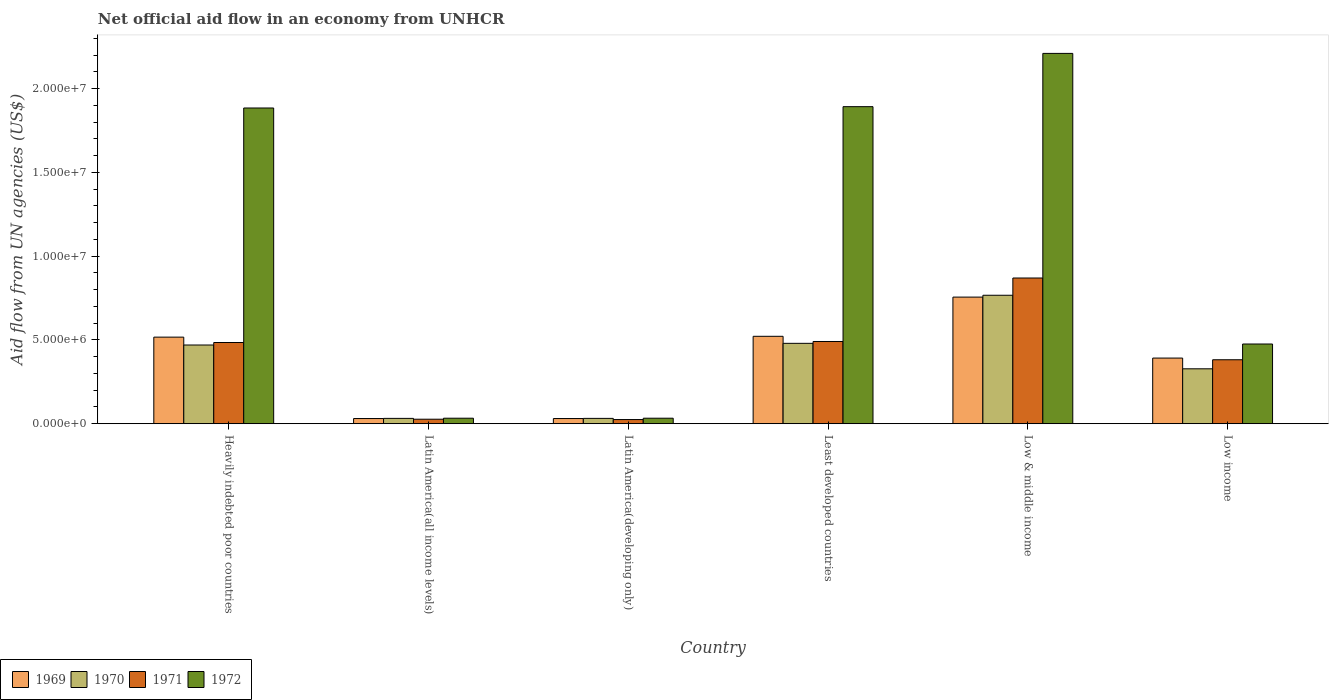How many groups of bars are there?
Offer a terse response. 6. Are the number of bars per tick equal to the number of legend labels?
Keep it short and to the point. Yes. How many bars are there on the 2nd tick from the left?
Your response must be concise. 4. What is the label of the 5th group of bars from the left?
Your answer should be very brief. Low & middle income. What is the net official aid flow in 1970 in Low & middle income?
Your answer should be very brief. 7.67e+06. Across all countries, what is the maximum net official aid flow in 1970?
Your response must be concise. 7.67e+06. Across all countries, what is the minimum net official aid flow in 1969?
Your answer should be compact. 3.10e+05. In which country was the net official aid flow in 1969 maximum?
Provide a short and direct response. Low & middle income. In which country was the net official aid flow in 1972 minimum?
Keep it short and to the point. Latin America(all income levels). What is the total net official aid flow in 1971 in the graph?
Keep it short and to the point. 2.28e+07. What is the difference between the net official aid flow in 1972 in Latin America(developing only) and that in Low income?
Offer a terse response. -4.43e+06. What is the difference between the net official aid flow in 1971 in Heavily indebted poor countries and the net official aid flow in 1969 in Latin America(all income levels)?
Give a very brief answer. 4.54e+06. What is the average net official aid flow in 1972 per country?
Your answer should be compact. 1.09e+07. What is the difference between the net official aid flow of/in 1971 and net official aid flow of/in 1970 in Latin America(all income levels)?
Your answer should be very brief. -5.00e+04. What is the ratio of the net official aid flow in 1969 in Least developed countries to that in Low income?
Your answer should be compact. 1.33. What is the difference between the highest and the second highest net official aid flow in 1971?
Provide a succinct answer. 3.85e+06. What is the difference between the highest and the lowest net official aid flow in 1971?
Your answer should be compact. 8.45e+06. In how many countries, is the net official aid flow in 1970 greater than the average net official aid flow in 1970 taken over all countries?
Make the answer very short. 3. Is the sum of the net official aid flow in 1972 in Heavily indebted poor countries and Least developed countries greater than the maximum net official aid flow in 1971 across all countries?
Your answer should be compact. Yes. What does the 4th bar from the left in Latin America(all income levels) represents?
Make the answer very short. 1972. What does the 4th bar from the right in Latin America(all income levels) represents?
Your answer should be very brief. 1969. Is it the case that in every country, the sum of the net official aid flow in 1971 and net official aid flow in 1972 is greater than the net official aid flow in 1969?
Provide a succinct answer. Yes. Are all the bars in the graph horizontal?
Your answer should be very brief. No. How many countries are there in the graph?
Your answer should be compact. 6. Where does the legend appear in the graph?
Your answer should be very brief. Bottom left. How many legend labels are there?
Offer a terse response. 4. How are the legend labels stacked?
Ensure brevity in your answer.  Horizontal. What is the title of the graph?
Your response must be concise. Net official aid flow in an economy from UNHCR. What is the label or title of the X-axis?
Offer a very short reply. Country. What is the label or title of the Y-axis?
Ensure brevity in your answer.  Aid flow from UN agencies (US$). What is the Aid flow from UN agencies (US$) of 1969 in Heavily indebted poor countries?
Make the answer very short. 5.17e+06. What is the Aid flow from UN agencies (US$) in 1970 in Heavily indebted poor countries?
Your answer should be compact. 4.70e+06. What is the Aid flow from UN agencies (US$) of 1971 in Heavily indebted poor countries?
Give a very brief answer. 4.85e+06. What is the Aid flow from UN agencies (US$) of 1972 in Heavily indebted poor countries?
Keep it short and to the point. 1.88e+07. What is the Aid flow from UN agencies (US$) of 1970 in Latin America(all income levels)?
Make the answer very short. 3.20e+05. What is the Aid flow from UN agencies (US$) of 1972 in Latin America(all income levels)?
Give a very brief answer. 3.30e+05. What is the Aid flow from UN agencies (US$) of 1969 in Latin America(developing only)?
Provide a short and direct response. 3.10e+05. What is the Aid flow from UN agencies (US$) of 1971 in Latin America(developing only)?
Provide a succinct answer. 2.50e+05. What is the Aid flow from UN agencies (US$) in 1969 in Least developed countries?
Your answer should be very brief. 5.22e+06. What is the Aid flow from UN agencies (US$) of 1970 in Least developed countries?
Provide a succinct answer. 4.80e+06. What is the Aid flow from UN agencies (US$) of 1971 in Least developed countries?
Your answer should be compact. 4.91e+06. What is the Aid flow from UN agencies (US$) of 1972 in Least developed countries?
Provide a succinct answer. 1.89e+07. What is the Aid flow from UN agencies (US$) of 1969 in Low & middle income?
Provide a succinct answer. 7.56e+06. What is the Aid flow from UN agencies (US$) in 1970 in Low & middle income?
Offer a very short reply. 7.67e+06. What is the Aid flow from UN agencies (US$) of 1971 in Low & middle income?
Your answer should be compact. 8.70e+06. What is the Aid flow from UN agencies (US$) in 1972 in Low & middle income?
Your answer should be compact. 2.21e+07. What is the Aid flow from UN agencies (US$) of 1969 in Low income?
Offer a very short reply. 3.92e+06. What is the Aid flow from UN agencies (US$) of 1970 in Low income?
Offer a terse response. 3.28e+06. What is the Aid flow from UN agencies (US$) of 1971 in Low income?
Provide a succinct answer. 3.82e+06. What is the Aid flow from UN agencies (US$) of 1972 in Low income?
Make the answer very short. 4.76e+06. Across all countries, what is the maximum Aid flow from UN agencies (US$) in 1969?
Give a very brief answer. 7.56e+06. Across all countries, what is the maximum Aid flow from UN agencies (US$) of 1970?
Ensure brevity in your answer.  7.67e+06. Across all countries, what is the maximum Aid flow from UN agencies (US$) in 1971?
Provide a succinct answer. 8.70e+06. Across all countries, what is the maximum Aid flow from UN agencies (US$) of 1972?
Keep it short and to the point. 2.21e+07. Across all countries, what is the minimum Aid flow from UN agencies (US$) in 1970?
Your response must be concise. 3.20e+05. Across all countries, what is the minimum Aid flow from UN agencies (US$) of 1971?
Provide a succinct answer. 2.50e+05. Across all countries, what is the minimum Aid flow from UN agencies (US$) of 1972?
Make the answer very short. 3.30e+05. What is the total Aid flow from UN agencies (US$) in 1969 in the graph?
Provide a short and direct response. 2.25e+07. What is the total Aid flow from UN agencies (US$) in 1970 in the graph?
Make the answer very short. 2.11e+07. What is the total Aid flow from UN agencies (US$) in 1971 in the graph?
Offer a terse response. 2.28e+07. What is the total Aid flow from UN agencies (US$) of 1972 in the graph?
Offer a terse response. 6.53e+07. What is the difference between the Aid flow from UN agencies (US$) in 1969 in Heavily indebted poor countries and that in Latin America(all income levels)?
Provide a succinct answer. 4.86e+06. What is the difference between the Aid flow from UN agencies (US$) of 1970 in Heavily indebted poor countries and that in Latin America(all income levels)?
Provide a succinct answer. 4.38e+06. What is the difference between the Aid flow from UN agencies (US$) in 1971 in Heavily indebted poor countries and that in Latin America(all income levels)?
Keep it short and to the point. 4.58e+06. What is the difference between the Aid flow from UN agencies (US$) of 1972 in Heavily indebted poor countries and that in Latin America(all income levels)?
Offer a very short reply. 1.85e+07. What is the difference between the Aid flow from UN agencies (US$) in 1969 in Heavily indebted poor countries and that in Latin America(developing only)?
Provide a short and direct response. 4.86e+06. What is the difference between the Aid flow from UN agencies (US$) of 1970 in Heavily indebted poor countries and that in Latin America(developing only)?
Offer a very short reply. 4.38e+06. What is the difference between the Aid flow from UN agencies (US$) of 1971 in Heavily indebted poor countries and that in Latin America(developing only)?
Your answer should be very brief. 4.60e+06. What is the difference between the Aid flow from UN agencies (US$) of 1972 in Heavily indebted poor countries and that in Latin America(developing only)?
Your answer should be compact. 1.85e+07. What is the difference between the Aid flow from UN agencies (US$) of 1969 in Heavily indebted poor countries and that in Least developed countries?
Ensure brevity in your answer.  -5.00e+04. What is the difference between the Aid flow from UN agencies (US$) in 1969 in Heavily indebted poor countries and that in Low & middle income?
Make the answer very short. -2.39e+06. What is the difference between the Aid flow from UN agencies (US$) of 1970 in Heavily indebted poor countries and that in Low & middle income?
Keep it short and to the point. -2.97e+06. What is the difference between the Aid flow from UN agencies (US$) of 1971 in Heavily indebted poor countries and that in Low & middle income?
Make the answer very short. -3.85e+06. What is the difference between the Aid flow from UN agencies (US$) in 1972 in Heavily indebted poor countries and that in Low & middle income?
Provide a succinct answer. -3.26e+06. What is the difference between the Aid flow from UN agencies (US$) in 1969 in Heavily indebted poor countries and that in Low income?
Your answer should be compact. 1.25e+06. What is the difference between the Aid flow from UN agencies (US$) of 1970 in Heavily indebted poor countries and that in Low income?
Your response must be concise. 1.42e+06. What is the difference between the Aid flow from UN agencies (US$) of 1971 in Heavily indebted poor countries and that in Low income?
Offer a very short reply. 1.03e+06. What is the difference between the Aid flow from UN agencies (US$) of 1972 in Heavily indebted poor countries and that in Low income?
Keep it short and to the point. 1.41e+07. What is the difference between the Aid flow from UN agencies (US$) in 1971 in Latin America(all income levels) and that in Latin America(developing only)?
Your response must be concise. 2.00e+04. What is the difference between the Aid flow from UN agencies (US$) of 1972 in Latin America(all income levels) and that in Latin America(developing only)?
Offer a terse response. 0. What is the difference between the Aid flow from UN agencies (US$) in 1969 in Latin America(all income levels) and that in Least developed countries?
Offer a terse response. -4.91e+06. What is the difference between the Aid flow from UN agencies (US$) in 1970 in Latin America(all income levels) and that in Least developed countries?
Ensure brevity in your answer.  -4.48e+06. What is the difference between the Aid flow from UN agencies (US$) of 1971 in Latin America(all income levels) and that in Least developed countries?
Ensure brevity in your answer.  -4.64e+06. What is the difference between the Aid flow from UN agencies (US$) of 1972 in Latin America(all income levels) and that in Least developed countries?
Offer a very short reply. -1.86e+07. What is the difference between the Aid flow from UN agencies (US$) in 1969 in Latin America(all income levels) and that in Low & middle income?
Offer a very short reply. -7.25e+06. What is the difference between the Aid flow from UN agencies (US$) of 1970 in Latin America(all income levels) and that in Low & middle income?
Keep it short and to the point. -7.35e+06. What is the difference between the Aid flow from UN agencies (US$) in 1971 in Latin America(all income levels) and that in Low & middle income?
Provide a short and direct response. -8.43e+06. What is the difference between the Aid flow from UN agencies (US$) of 1972 in Latin America(all income levels) and that in Low & middle income?
Your answer should be very brief. -2.18e+07. What is the difference between the Aid flow from UN agencies (US$) of 1969 in Latin America(all income levels) and that in Low income?
Offer a terse response. -3.61e+06. What is the difference between the Aid flow from UN agencies (US$) of 1970 in Latin America(all income levels) and that in Low income?
Make the answer very short. -2.96e+06. What is the difference between the Aid flow from UN agencies (US$) of 1971 in Latin America(all income levels) and that in Low income?
Offer a very short reply. -3.55e+06. What is the difference between the Aid flow from UN agencies (US$) in 1972 in Latin America(all income levels) and that in Low income?
Give a very brief answer. -4.43e+06. What is the difference between the Aid flow from UN agencies (US$) of 1969 in Latin America(developing only) and that in Least developed countries?
Keep it short and to the point. -4.91e+06. What is the difference between the Aid flow from UN agencies (US$) of 1970 in Latin America(developing only) and that in Least developed countries?
Your answer should be very brief. -4.48e+06. What is the difference between the Aid flow from UN agencies (US$) in 1971 in Latin America(developing only) and that in Least developed countries?
Offer a very short reply. -4.66e+06. What is the difference between the Aid flow from UN agencies (US$) of 1972 in Latin America(developing only) and that in Least developed countries?
Keep it short and to the point. -1.86e+07. What is the difference between the Aid flow from UN agencies (US$) of 1969 in Latin America(developing only) and that in Low & middle income?
Your answer should be compact. -7.25e+06. What is the difference between the Aid flow from UN agencies (US$) of 1970 in Latin America(developing only) and that in Low & middle income?
Your answer should be compact. -7.35e+06. What is the difference between the Aid flow from UN agencies (US$) of 1971 in Latin America(developing only) and that in Low & middle income?
Your answer should be compact. -8.45e+06. What is the difference between the Aid flow from UN agencies (US$) in 1972 in Latin America(developing only) and that in Low & middle income?
Your answer should be very brief. -2.18e+07. What is the difference between the Aid flow from UN agencies (US$) of 1969 in Latin America(developing only) and that in Low income?
Provide a short and direct response. -3.61e+06. What is the difference between the Aid flow from UN agencies (US$) in 1970 in Latin America(developing only) and that in Low income?
Ensure brevity in your answer.  -2.96e+06. What is the difference between the Aid flow from UN agencies (US$) in 1971 in Latin America(developing only) and that in Low income?
Make the answer very short. -3.57e+06. What is the difference between the Aid flow from UN agencies (US$) of 1972 in Latin America(developing only) and that in Low income?
Provide a succinct answer. -4.43e+06. What is the difference between the Aid flow from UN agencies (US$) in 1969 in Least developed countries and that in Low & middle income?
Offer a very short reply. -2.34e+06. What is the difference between the Aid flow from UN agencies (US$) in 1970 in Least developed countries and that in Low & middle income?
Provide a succinct answer. -2.87e+06. What is the difference between the Aid flow from UN agencies (US$) in 1971 in Least developed countries and that in Low & middle income?
Offer a very short reply. -3.79e+06. What is the difference between the Aid flow from UN agencies (US$) in 1972 in Least developed countries and that in Low & middle income?
Keep it short and to the point. -3.18e+06. What is the difference between the Aid flow from UN agencies (US$) in 1969 in Least developed countries and that in Low income?
Your answer should be very brief. 1.30e+06. What is the difference between the Aid flow from UN agencies (US$) of 1970 in Least developed countries and that in Low income?
Keep it short and to the point. 1.52e+06. What is the difference between the Aid flow from UN agencies (US$) of 1971 in Least developed countries and that in Low income?
Your answer should be compact. 1.09e+06. What is the difference between the Aid flow from UN agencies (US$) of 1972 in Least developed countries and that in Low income?
Provide a short and direct response. 1.42e+07. What is the difference between the Aid flow from UN agencies (US$) of 1969 in Low & middle income and that in Low income?
Make the answer very short. 3.64e+06. What is the difference between the Aid flow from UN agencies (US$) in 1970 in Low & middle income and that in Low income?
Provide a succinct answer. 4.39e+06. What is the difference between the Aid flow from UN agencies (US$) of 1971 in Low & middle income and that in Low income?
Your response must be concise. 4.88e+06. What is the difference between the Aid flow from UN agencies (US$) in 1972 in Low & middle income and that in Low income?
Give a very brief answer. 1.74e+07. What is the difference between the Aid flow from UN agencies (US$) in 1969 in Heavily indebted poor countries and the Aid flow from UN agencies (US$) in 1970 in Latin America(all income levels)?
Provide a succinct answer. 4.85e+06. What is the difference between the Aid flow from UN agencies (US$) of 1969 in Heavily indebted poor countries and the Aid flow from UN agencies (US$) of 1971 in Latin America(all income levels)?
Offer a very short reply. 4.90e+06. What is the difference between the Aid flow from UN agencies (US$) in 1969 in Heavily indebted poor countries and the Aid flow from UN agencies (US$) in 1972 in Latin America(all income levels)?
Provide a succinct answer. 4.84e+06. What is the difference between the Aid flow from UN agencies (US$) of 1970 in Heavily indebted poor countries and the Aid flow from UN agencies (US$) of 1971 in Latin America(all income levels)?
Your response must be concise. 4.43e+06. What is the difference between the Aid flow from UN agencies (US$) of 1970 in Heavily indebted poor countries and the Aid flow from UN agencies (US$) of 1972 in Latin America(all income levels)?
Ensure brevity in your answer.  4.37e+06. What is the difference between the Aid flow from UN agencies (US$) in 1971 in Heavily indebted poor countries and the Aid flow from UN agencies (US$) in 1972 in Latin America(all income levels)?
Keep it short and to the point. 4.52e+06. What is the difference between the Aid flow from UN agencies (US$) of 1969 in Heavily indebted poor countries and the Aid flow from UN agencies (US$) of 1970 in Latin America(developing only)?
Offer a terse response. 4.85e+06. What is the difference between the Aid flow from UN agencies (US$) of 1969 in Heavily indebted poor countries and the Aid flow from UN agencies (US$) of 1971 in Latin America(developing only)?
Make the answer very short. 4.92e+06. What is the difference between the Aid flow from UN agencies (US$) in 1969 in Heavily indebted poor countries and the Aid flow from UN agencies (US$) in 1972 in Latin America(developing only)?
Your answer should be very brief. 4.84e+06. What is the difference between the Aid flow from UN agencies (US$) in 1970 in Heavily indebted poor countries and the Aid flow from UN agencies (US$) in 1971 in Latin America(developing only)?
Keep it short and to the point. 4.45e+06. What is the difference between the Aid flow from UN agencies (US$) in 1970 in Heavily indebted poor countries and the Aid flow from UN agencies (US$) in 1972 in Latin America(developing only)?
Your response must be concise. 4.37e+06. What is the difference between the Aid flow from UN agencies (US$) of 1971 in Heavily indebted poor countries and the Aid flow from UN agencies (US$) of 1972 in Latin America(developing only)?
Keep it short and to the point. 4.52e+06. What is the difference between the Aid flow from UN agencies (US$) in 1969 in Heavily indebted poor countries and the Aid flow from UN agencies (US$) in 1970 in Least developed countries?
Your response must be concise. 3.70e+05. What is the difference between the Aid flow from UN agencies (US$) in 1969 in Heavily indebted poor countries and the Aid flow from UN agencies (US$) in 1971 in Least developed countries?
Provide a short and direct response. 2.60e+05. What is the difference between the Aid flow from UN agencies (US$) in 1969 in Heavily indebted poor countries and the Aid flow from UN agencies (US$) in 1972 in Least developed countries?
Make the answer very short. -1.38e+07. What is the difference between the Aid flow from UN agencies (US$) in 1970 in Heavily indebted poor countries and the Aid flow from UN agencies (US$) in 1972 in Least developed countries?
Give a very brief answer. -1.42e+07. What is the difference between the Aid flow from UN agencies (US$) of 1971 in Heavily indebted poor countries and the Aid flow from UN agencies (US$) of 1972 in Least developed countries?
Ensure brevity in your answer.  -1.41e+07. What is the difference between the Aid flow from UN agencies (US$) in 1969 in Heavily indebted poor countries and the Aid flow from UN agencies (US$) in 1970 in Low & middle income?
Offer a terse response. -2.50e+06. What is the difference between the Aid flow from UN agencies (US$) of 1969 in Heavily indebted poor countries and the Aid flow from UN agencies (US$) of 1971 in Low & middle income?
Provide a succinct answer. -3.53e+06. What is the difference between the Aid flow from UN agencies (US$) of 1969 in Heavily indebted poor countries and the Aid flow from UN agencies (US$) of 1972 in Low & middle income?
Ensure brevity in your answer.  -1.69e+07. What is the difference between the Aid flow from UN agencies (US$) of 1970 in Heavily indebted poor countries and the Aid flow from UN agencies (US$) of 1971 in Low & middle income?
Ensure brevity in your answer.  -4.00e+06. What is the difference between the Aid flow from UN agencies (US$) in 1970 in Heavily indebted poor countries and the Aid flow from UN agencies (US$) in 1972 in Low & middle income?
Offer a terse response. -1.74e+07. What is the difference between the Aid flow from UN agencies (US$) in 1971 in Heavily indebted poor countries and the Aid flow from UN agencies (US$) in 1972 in Low & middle income?
Make the answer very short. -1.73e+07. What is the difference between the Aid flow from UN agencies (US$) of 1969 in Heavily indebted poor countries and the Aid flow from UN agencies (US$) of 1970 in Low income?
Provide a short and direct response. 1.89e+06. What is the difference between the Aid flow from UN agencies (US$) of 1969 in Heavily indebted poor countries and the Aid flow from UN agencies (US$) of 1971 in Low income?
Your response must be concise. 1.35e+06. What is the difference between the Aid flow from UN agencies (US$) in 1970 in Heavily indebted poor countries and the Aid flow from UN agencies (US$) in 1971 in Low income?
Your response must be concise. 8.80e+05. What is the difference between the Aid flow from UN agencies (US$) in 1970 in Heavily indebted poor countries and the Aid flow from UN agencies (US$) in 1972 in Low income?
Provide a succinct answer. -6.00e+04. What is the difference between the Aid flow from UN agencies (US$) of 1971 in Heavily indebted poor countries and the Aid flow from UN agencies (US$) of 1972 in Low income?
Provide a short and direct response. 9.00e+04. What is the difference between the Aid flow from UN agencies (US$) of 1969 in Latin America(all income levels) and the Aid flow from UN agencies (US$) of 1972 in Latin America(developing only)?
Offer a terse response. -2.00e+04. What is the difference between the Aid flow from UN agencies (US$) of 1970 in Latin America(all income levels) and the Aid flow from UN agencies (US$) of 1971 in Latin America(developing only)?
Ensure brevity in your answer.  7.00e+04. What is the difference between the Aid flow from UN agencies (US$) in 1970 in Latin America(all income levels) and the Aid flow from UN agencies (US$) in 1972 in Latin America(developing only)?
Make the answer very short. -10000. What is the difference between the Aid flow from UN agencies (US$) of 1969 in Latin America(all income levels) and the Aid flow from UN agencies (US$) of 1970 in Least developed countries?
Your answer should be very brief. -4.49e+06. What is the difference between the Aid flow from UN agencies (US$) in 1969 in Latin America(all income levels) and the Aid flow from UN agencies (US$) in 1971 in Least developed countries?
Your answer should be very brief. -4.60e+06. What is the difference between the Aid flow from UN agencies (US$) in 1969 in Latin America(all income levels) and the Aid flow from UN agencies (US$) in 1972 in Least developed countries?
Give a very brief answer. -1.86e+07. What is the difference between the Aid flow from UN agencies (US$) in 1970 in Latin America(all income levels) and the Aid flow from UN agencies (US$) in 1971 in Least developed countries?
Offer a very short reply. -4.59e+06. What is the difference between the Aid flow from UN agencies (US$) in 1970 in Latin America(all income levels) and the Aid flow from UN agencies (US$) in 1972 in Least developed countries?
Offer a very short reply. -1.86e+07. What is the difference between the Aid flow from UN agencies (US$) in 1971 in Latin America(all income levels) and the Aid flow from UN agencies (US$) in 1972 in Least developed countries?
Your answer should be compact. -1.87e+07. What is the difference between the Aid flow from UN agencies (US$) in 1969 in Latin America(all income levels) and the Aid flow from UN agencies (US$) in 1970 in Low & middle income?
Give a very brief answer. -7.36e+06. What is the difference between the Aid flow from UN agencies (US$) in 1969 in Latin America(all income levels) and the Aid flow from UN agencies (US$) in 1971 in Low & middle income?
Make the answer very short. -8.39e+06. What is the difference between the Aid flow from UN agencies (US$) in 1969 in Latin America(all income levels) and the Aid flow from UN agencies (US$) in 1972 in Low & middle income?
Offer a terse response. -2.18e+07. What is the difference between the Aid flow from UN agencies (US$) in 1970 in Latin America(all income levels) and the Aid flow from UN agencies (US$) in 1971 in Low & middle income?
Provide a succinct answer. -8.38e+06. What is the difference between the Aid flow from UN agencies (US$) in 1970 in Latin America(all income levels) and the Aid flow from UN agencies (US$) in 1972 in Low & middle income?
Keep it short and to the point. -2.18e+07. What is the difference between the Aid flow from UN agencies (US$) in 1971 in Latin America(all income levels) and the Aid flow from UN agencies (US$) in 1972 in Low & middle income?
Provide a short and direct response. -2.18e+07. What is the difference between the Aid flow from UN agencies (US$) of 1969 in Latin America(all income levels) and the Aid flow from UN agencies (US$) of 1970 in Low income?
Offer a very short reply. -2.97e+06. What is the difference between the Aid flow from UN agencies (US$) in 1969 in Latin America(all income levels) and the Aid flow from UN agencies (US$) in 1971 in Low income?
Offer a very short reply. -3.51e+06. What is the difference between the Aid flow from UN agencies (US$) of 1969 in Latin America(all income levels) and the Aid flow from UN agencies (US$) of 1972 in Low income?
Make the answer very short. -4.45e+06. What is the difference between the Aid flow from UN agencies (US$) of 1970 in Latin America(all income levels) and the Aid flow from UN agencies (US$) of 1971 in Low income?
Keep it short and to the point. -3.50e+06. What is the difference between the Aid flow from UN agencies (US$) of 1970 in Latin America(all income levels) and the Aid flow from UN agencies (US$) of 1972 in Low income?
Your answer should be compact. -4.44e+06. What is the difference between the Aid flow from UN agencies (US$) of 1971 in Latin America(all income levels) and the Aid flow from UN agencies (US$) of 1972 in Low income?
Offer a very short reply. -4.49e+06. What is the difference between the Aid flow from UN agencies (US$) in 1969 in Latin America(developing only) and the Aid flow from UN agencies (US$) in 1970 in Least developed countries?
Your answer should be compact. -4.49e+06. What is the difference between the Aid flow from UN agencies (US$) in 1969 in Latin America(developing only) and the Aid flow from UN agencies (US$) in 1971 in Least developed countries?
Offer a terse response. -4.60e+06. What is the difference between the Aid flow from UN agencies (US$) of 1969 in Latin America(developing only) and the Aid flow from UN agencies (US$) of 1972 in Least developed countries?
Offer a terse response. -1.86e+07. What is the difference between the Aid flow from UN agencies (US$) of 1970 in Latin America(developing only) and the Aid flow from UN agencies (US$) of 1971 in Least developed countries?
Your answer should be compact. -4.59e+06. What is the difference between the Aid flow from UN agencies (US$) of 1970 in Latin America(developing only) and the Aid flow from UN agencies (US$) of 1972 in Least developed countries?
Provide a short and direct response. -1.86e+07. What is the difference between the Aid flow from UN agencies (US$) of 1971 in Latin America(developing only) and the Aid flow from UN agencies (US$) of 1972 in Least developed countries?
Provide a short and direct response. -1.87e+07. What is the difference between the Aid flow from UN agencies (US$) in 1969 in Latin America(developing only) and the Aid flow from UN agencies (US$) in 1970 in Low & middle income?
Your response must be concise. -7.36e+06. What is the difference between the Aid flow from UN agencies (US$) in 1969 in Latin America(developing only) and the Aid flow from UN agencies (US$) in 1971 in Low & middle income?
Provide a succinct answer. -8.39e+06. What is the difference between the Aid flow from UN agencies (US$) in 1969 in Latin America(developing only) and the Aid flow from UN agencies (US$) in 1972 in Low & middle income?
Give a very brief answer. -2.18e+07. What is the difference between the Aid flow from UN agencies (US$) of 1970 in Latin America(developing only) and the Aid flow from UN agencies (US$) of 1971 in Low & middle income?
Ensure brevity in your answer.  -8.38e+06. What is the difference between the Aid flow from UN agencies (US$) of 1970 in Latin America(developing only) and the Aid flow from UN agencies (US$) of 1972 in Low & middle income?
Ensure brevity in your answer.  -2.18e+07. What is the difference between the Aid flow from UN agencies (US$) of 1971 in Latin America(developing only) and the Aid flow from UN agencies (US$) of 1972 in Low & middle income?
Offer a terse response. -2.19e+07. What is the difference between the Aid flow from UN agencies (US$) in 1969 in Latin America(developing only) and the Aid flow from UN agencies (US$) in 1970 in Low income?
Your answer should be very brief. -2.97e+06. What is the difference between the Aid flow from UN agencies (US$) of 1969 in Latin America(developing only) and the Aid flow from UN agencies (US$) of 1971 in Low income?
Give a very brief answer. -3.51e+06. What is the difference between the Aid flow from UN agencies (US$) in 1969 in Latin America(developing only) and the Aid flow from UN agencies (US$) in 1972 in Low income?
Make the answer very short. -4.45e+06. What is the difference between the Aid flow from UN agencies (US$) of 1970 in Latin America(developing only) and the Aid flow from UN agencies (US$) of 1971 in Low income?
Make the answer very short. -3.50e+06. What is the difference between the Aid flow from UN agencies (US$) of 1970 in Latin America(developing only) and the Aid flow from UN agencies (US$) of 1972 in Low income?
Provide a succinct answer. -4.44e+06. What is the difference between the Aid flow from UN agencies (US$) of 1971 in Latin America(developing only) and the Aid flow from UN agencies (US$) of 1972 in Low income?
Provide a short and direct response. -4.51e+06. What is the difference between the Aid flow from UN agencies (US$) of 1969 in Least developed countries and the Aid flow from UN agencies (US$) of 1970 in Low & middle income?
Provide a short and direct response. -2.45e+06. What is the difference between the Aid flow from UN agencies (US$) in 1969 in Least developed countries and the Aid flow from UN agencies (US$) in 1971 in Low & middle income?
Your answer should be very brief. -3.48e+06. What is the difference between the Aid flow from UN agencies (US$) in 1969 in Least developed countries and the Aid flow from UN agencies (US$) in 1972 in Low & middle income?
Your response must be concise. -1.69e+07. What is the difference between the Aid flow from UN agencies (US$) of 1970 in Least developed countries and the Aid flow from UN agencies (US$) of 1971 in Low & middle income?
Make the answer very short. -3.90e+06. What is the difference between the Aid flow from UN agencies (US$) in 1970 in Least developed countries and the Aid flow from UN agencies (US$) in 1972 in Low & middle income?
Provide a short and direct response. -1.73e+07. What is the difference between the Aid flow from UN agencies (US$) in 1971 in Least developed countries and the Aid flow from UN agencies (US$) in 1972 in Low & middle income?
Provide a succinct answer. -1.72e+07. What is the difference between the Aid flow from UN agencies (US$) of 1969 in Least developed countries and the Aid flow from UN agencies (US$) of 1970 in Low income?
Keep it short and to the point. 1.94e+06. What is the difference between the Aid flow from UN agencies (US$) of 1969 in Least developed countries and the Aid flow from UN agencies (US$) of 1971 in Low income?
Keep it short and to the point. 1.40e+06. What is the difference between the Aid flow from UN agencies (US$) of 1970 in Least developed countries and the Aid flow from UN agencies (US$) of 1971 in Low income?
Offer a very short reply. 9.80e+05. What is the difference between the Aid flow from UN agencies (US$) in 1970 in Least developed countries and the Aid flow from UN agencies (US$) in 1972 in Low income?
Provide a short and direct response. 4.00e+04. What is the difference between the Aid flow from UN agencies (US$) in 1969 in Low & middle income and the Aid flow from UN agencies (US$) in 1970 in Low income?
Your answer should be very brief. 4.28e+06. What is the difference between the Aid flow from UN agencies (US$) of 1969 in Low & middle income and the Aid flow from UN agencies (US$) of 1971 in Low income?
Make the answer very short. 3.74e+06. What is the difference between the Aid flow from UN agencies (US$) in 1969 in Low & middle income and the Aid flow from UN agencies (US$) in 1972 in Low income?
Offer a terse response. 2.80e+06. What is the difference between the Aid flow from UN agencies (US$) in 1970 in Low & middle income and the Aid flow from UN agencies (US$) in 1971 in Low income?
Make the answer very short. 3.85e+06. What is the difference between the Aid flow from UN agencies (US$) of 1970 in Low & middle income and the Aid flow from UN agencies (US$) of 1972 in Low income?
Offer a very short reply. 2.91e+06. What is the difference between the Aid flow from UN agencies (US$) of 1971 in Low & middle income and the Aid flow from UN agencies (US$) of 1972 in Low income?
Offer a terse response. 3.94e+06. What is the average Aid flow from UN agencies (US$) of 1969 per country?
Keep it short and to the point. 3.75e+06. What is the average Aid flow from UN agencies (US$) in 1970 per country?
Give a very brief answer. 3.52e+06. What is the average Aid flow from UN agencies (US$) in 1971 per country?
Offer a very short reply. 3.80e+06. What is the average Aid flow from UN agencies (US$) in 1972 per country?
Your answer should be very brief. 1.09e+07. What is the difference between the Aid flow from UN agencies (US$) of 1969 and Aid flow from UN agencies (US$) of 1972 in Heavily indebted poor countries?
Give a very brief answer. -1.37e+07. What is the difference between the Aid flow from UN agencies (US$) in 1970 and Aid flow from UN agencies (US$) in 1971 in Heavily indebted poor countries?
Your answer should be very brief. -1.50e+05. What is the difference between the Aid flow from UN agencies (US$) in 1970 and Aid flow from UN agencies (US$) in 1972 in Heavily indebted poor countries?
Keep it short and to the point. -1.42e+07. What is the difference between the Aid flow from UN agencies (US$) in 1971 and Aid flow from UN agencies (US$) in 1972 in Heavily indebted poor countries?
Provide a succinct answer. -1.40e+07. What is the difference between the Aid flow from UN agencies (US$) of 1969 and Aid flow from UN agencies (US$) of 1971 in Latin America(all income levels)?
Give a very brief answer. 4.00e+04. What is the difference between the Aid flow from UN agencies (US$) of 1969 and Aid flow from UN agencies (US$) of 1970 in Latin America(developing only)?
Your answer should be compact. -10000. What is the difference between the Aid flow from UN agencies (US$) in 1971 and Aid flow from UN agencies (US$) in 1972 in Latin America(developing only)?
Offer a very short reply. -8.00e+04. What is the difference between the Aid flow from UN agencies (US$) in 1969 and Aid flow from UN agencies (US$) in 1970 in Least developed countries?
Provide a short and direct response. 4.20e+05. What is the difference between the Aid flow from UN agencies (US$) in 1969 and Aid flow from UN agencies (US$) in 1972 in Least developed countries?
Keep it short and to the point. -1.37e+07. What is the difference between the Aid flow from UN agencies (US$) in 1970 and Aid flow from UN agencies (US$) in 1971 in Least developed countries?
Your answer should be very brief. -1.10e+05. What is the difference between the Aid flow from UN agencies (US$) in 1970 and Aid flow from UN agencies (US$) in 1972 in Least developed countries?
Your response must be concise. -1.41e+07. What is the difference between the Aid flow from UN agencies (US$) in 1971 and Aid flow from UN agencies (US$) in 1972 in Least developed countries?
Offer a terse response. -1.40e+07. What is the difference between the Aid flow from UN agencies (US$) of 1969 and Aid flow from UN agencies (US$) of 1971 in Low & middle income?
Provide a short and direct response. -1.14e+06. What is the difference between the Aid flow from UN agencies (US$) in 1969 and Aid flow from UN agencies (US$) in 1972 in Low & middle income?
Your response must be concise. -1.46e+07. What is the difference between the Aid flow from UN agencies (US$) in 1970 and Aid flow from UN agencies (US$) in 1971 in Low & middle income?
Make the answer very short. -1.03e+06. What is the difference between the Aid flow from UN agencies (US$) of 1970 and Aid flow from UN agencies (US$) of 1972 in Low & middle income?
Make the answer very short. -1.44e+07. What is the difference between the Aid flow from UN agencies (US$) of 1971 and Aid flow from UN agencies (US$) of 1972 in Low & middle income?
Your answer should be compact. -1.34e+07. What is the difference between the Aid flow from UN agencies (US$) in 1969 and Aid flow from UN agencies (US$) in 1970 in Low income?
Your answer should be compact. 6.40e+05. What is the difference between the Aid flow from UN agencies (US$) of 1969 and Aid flow from UN agencies (US$) of 1971 in Low income?
Provide a succinct answer. 1.00e+05. What is the difference between the Aid flow from UN agencies (US$) of 1969 and Aid flow from UN agencies (US$) of 1972 in Low income?
Give a very brief answer. -8.40e+05. What is the difference between the Aid flow from UN agencies (US$) in 1970 and Aid flow from UN agencies (US$) in 1971 in Low income?
Your answer should be very brief. -5.40e+05. What is the difference between the Aid flow from UN agencies (US$) of 1970 and Aid flow from UN agencies (US$) of 1972 in Low income?
Give a very brief answer. -1.48e+06. What is the difference between the Aid flow from UN agencies (US$) of 1971 and Aid flow from UN agencies (US$) of 1972 in Low income?
Your answer should be very brief. -9.40e+05. What is the ratio of the Aid flow from UN agencies (US$) of 1969 in Heavily indebted poor countries to that in Latin America(all income levels)?
Make the answer very short. 16.68. What is the ratio of the Aid flow from UN agencies (US$) in 1970 in Heavily indebted poor countries to that in Latin America(all income levels)?
Give a very brief answer. 14.69. What is the ratio of the Aid flow from UN agencies (US$) of 1971 in Heavily indebted poor countries to that in Latin America(all income levels)?
Keep it short and to the point. 17.96. What is the ratio of the Aid flow from UN agencies (US$) in 1972 in Heavily indebted poor countries to that in Latin America(all income levels)?
Provide a short and direct response. 57.12. What is the ratio of the Aid flow from UN agencies (US$) of 1969 in Heavily indebted poor countries to that in Latin America(developing only)?
Keep it short and to the point. 16.68. What is the ratio of the Aid flow from UN agencies (US$) in 1970 in Heavily indebted poor countries to that in Latin America(developing only)?
Offer a terse response. 14.69. What is the ratio of the Aid flow from UN agencies (US$) of 1971 in Heavily indebted poor countries to that in Latin America(developing only)?
Keep it short and to the point. 19.4. What is the ratio of the Aid flow from UN agencies (US$) in 1972 in Heavily indebted poor countries to that in Latin America(developing only)?
Offer a very short reply. 57.12. What is the ratio of the Aid flow from UN agencies (US$) of 1970 in Heavily indebted poor countries to that in Least developed countries?
Offer a very short reply. 0.98. What is the ratio of the Aid flow from UN agencies (US$) of 1969 in Heavily indebted poor countries to that in Low & middle income?
Your answer should be very brief. 0.68. What is the ratio of the Aid flow from UN agencies (US$) in 1970 in Heavily indebted poor countries to that in Low & middle income?
Provide a short and direct response. 0.61. What is the ratio of the Aid flow from UN agencies (US$) in 1971 in Heavily indebted poor countries to that in Low & middle income?
Your answer should be compact. 0.56. What is the ratio of the Aid flow from UN agencies (US$) in 1972 in Heavily indebted poor countries to that in Low & middle income?
Ensure brevity in your answer.  0.85. What is the ratio of the Aid flow from UN agencies (US$) of 1969 in Heavily indebted poor countries to that in Low income?
Ensure brevity in your answer.  1.32. What is the ratio of the Aid flow from UN agencies (US$) in 1970 in Heavily indebted poor countries to that in Low income?
Keep it short and to the point. 1.43. What is the ratio of the Aid flow from UN agencies (US$) in 1971 in Heavily indebted poor countries to that in Low income?
Keep it short and to the point. 1.27. What is the ratio of the Aid flow from UN agencies (US$) in 1972 in Heavily indebted poor countries to that in Low income?
Your response must be concise. 3.96. What is the ratio of the Aid flow from UN agencies (US$) in 1970 in Latin America(all income levels) to that in Latin America(developing only)?
Make the answer very short. 1. What is the ratio of the Aid flow from UN agencies (US$) in 1971 in Latin America(all income levels) to that in Latin America(developing only)?
Give a very brief answer. 1.08. What is the ratio of the Aid flow from UN agencies (US$) in 1969 in Latin America(all income levels) to that in Least developed countries?
Provide a succinct answer. 0.06. What is the ratio of the Aid flow from UN agencies (US$) in 1970 in Latin America(all income levels) to that in Least developed countries?
Offer a very short reply. 0.07. What is the ratio of the Aid flow from UN agencies (US$) of 1971 in Latin America(all income levels) to that in Least developed countries?
Give a very brief answer. 0.06. What is the ratio of the Aid flow from UN agencies (US$) of 1972 in Latin America(all income levels) to that in Least developed countries?
Provide a succinct answer. 0.02. What is the ratio of the Aid flow from UN agencies (US$) of 1969 in Latin America(all income levels) to that in Low & middle income?
Provide a short and direct response. 0.04. What is the ratio of the Aid flow from UN agencies (US$) of 1970 in Latin America(all income levels) to that in Low & middle income?
Provide a short and direct response. 0.04. What is the ratio of the Aid flow from UN agencies (US$) of 1971 in Latin America(all income levels) to that in Low & middle income?
Provide a succinct answer. 0.03. What is the ratio of the Aid flow from UN agencies (US$) of 1972 in Latin America(all income levels) to that in Low & middle income?
Give a very brief answer. 0.01. What is the ratio of the Aid flow from UN agencies (US$) of 1969 in Latin America(all income levels) to that in Low income?
Offer a very short reply. 0.08. What is the ratio of the Aid flow from UN agencies (US$) in 1970 in Latin America(all income levels) to that in Low income?
Ensure brevity in your answer.  0.1. What is the ratio of the Aid flow from UN agencies (US$) of 1971 in Latin America(all income levels) to that in Low income?
Provide a succinct answer. 0.07. What is the ratio of the Aid flow from UN agencies (US$) in 1972 in Latin America(all income levels) to that in Low income?
Your response must be concise. 0.07. What is the ratio of the Aid flow from UN agencies (US$) in 1969 in Latin America(developing only) to that in Least developed countries?
Keep it short and to the point. 0.06. What is the ratio of the Aid flow from UN agencies (US$) in 1970 in Latin America(developing only) to that in Least developed countries?
Give a very brief answer. 0.07. What is the ratio of the Aid flow from UN agencies (US$) of 1971 in Latin America(developing only) to that in Least developed countries?
Keep it short and to the point. 0.05. What is the ratio of the Aid flow from UN agencies (US$) in 1972 in Latin America(developing only) to that in Least developed countries?
Keep it short and to the point. 0.02. What is the ratio of the Aid flow from UN agencies (US$) in 1969 in Latin America(developing only) to that in Low & middle income?
Your answer should be very brief. 0.04. What is the ratio of the Aid flow from UN agencies (US$) of 1970 in Latin America(developing only) to that in Low & middle income?
Your answer should be very brief. 0.04. What is the ratio of the Aid flow from UN agencies (US$) of 1971 in Latin America(developing only) to that in Low & middle income?
Offer a very short reply. 0.03. What is the ratio of the Aid flow from UN agencies (US$) of 1972 in Latin America(developing only) to that in Low & middle income?
Offer a terse response. 0.01. What is the ratio of the Aid flow from UN agencies (US$) in 1969 in Latin America(developing only) to that in Low income?
Offer a terse response. 0.08. What is the ratio of the Aid flow from UN agencies (US$) of 1970 in Latin America(developing only) to that in Low income?
Your answer should be very brief. 0.1. What is the ratio of the Aid flow from UN agencies (US$) in 1971 in Latin America(developing only) to that in Low income?
Your answer should be compact. 0.07. What is the ratio of the Aid flow from UN agencies (US$) of 1972 in Latin America(developing only) to that in Low income?
Your response must be concise. 0.07. What is the ratio of the Aid flow from UN agencies (US$) of 1969 in Least developed countries to that in Low & middle income?
Provide a succinct answer. 0.69. What is the ratio of the Aid flow from UN agencies (US$) in 1970 in Least developed countries to that in Low & middle income?
Make the answer very short. 0.63. What is the ratio of the Aid flow from UN agencies (US$) in 1971 in Least developed countries to that in Low & middle income?
Ensure brevity in your answer.  0.56. What is the ratio of the Aid flow from UN agencies (US$) in 1972 in Least developed countries to that in Low & middle income?
Offer a terse response. 0.86. What is the ratio of the Aid flow from UN agencies (US$) in 1969 in Least developed countries to that in Low income?
Give a very brief answer. 1.33. What is the ratio of the Aid flow from UN agencies (US$) in 1970 in Least developed countries to that in Low income?
Your answer should be very brief. 1.46. What is the ratio of the Aid flow from UN agencies (US$) in 1971 in Least developed countries to that in Low income?
Ensure brevity in your answer.  1.29. What is the ratio of the Aid flow from UN agencies (US$) of 1972 in Least developed countries to that in Low income?
Your answer should be compact. 3.98. What is the ratio of the Aid flow from UN agencies (US$) in 1969 in Low & middle income to that in Low income?
Keep it short and to the point. 1.93. What is the ratio of the Aid flow from UN agencies (US$) in 1970 in Low & middle income to that in Low income?
Ensure brevity in your answer.  2.34. What is the ratio of the Aid flow from UN agencies (US$) in 1971 in Low & middle income to that in Low income?
Provide a succinct answer. 2.28. What is the ratio of the Aid flow from UN agencies (US$) in 1972 in Low & middle income to that in Low income?
Make the answer very short. 4.64. What is the difference between the highest and the second highest Aid flow from UN agencies (US$) of 1969?
Your answer should be very brief. 2.34e+06. What is the difference between the highest and the second highest Aid flow from UN agencies (US$) of 1970?
Make the answer very short. 2.87e+06. What is the difference between the highest and the second highest Aid flow from UN agencies (US$) of 1971?
Your answer should be very brief. 3.79e+06. What is the difference between the highest and the second highest Aid flow from UN agencies (US$) in 1972?
Offer a terse response. 3.18e+06. What is the difference between the highest and the lowest Aid flow from UN agencies (US$) in 1969?
Provide a succinct answer. 7.25e+06. What is the difference between the highest and the lowest Aid flow from UN agencies (US$) in 1970?
Keep it short and to the point. 7.35e+06. What is the difference between the highest and the lowest Aid flow from UN agencies (US$) in 1971?
Offer a terse response. 8.45e+06. What is the difference between the highest and the lowest Aid flow from UN agencies (US$) in 1972?
Keep it short and to the point. 2.18e+07. 